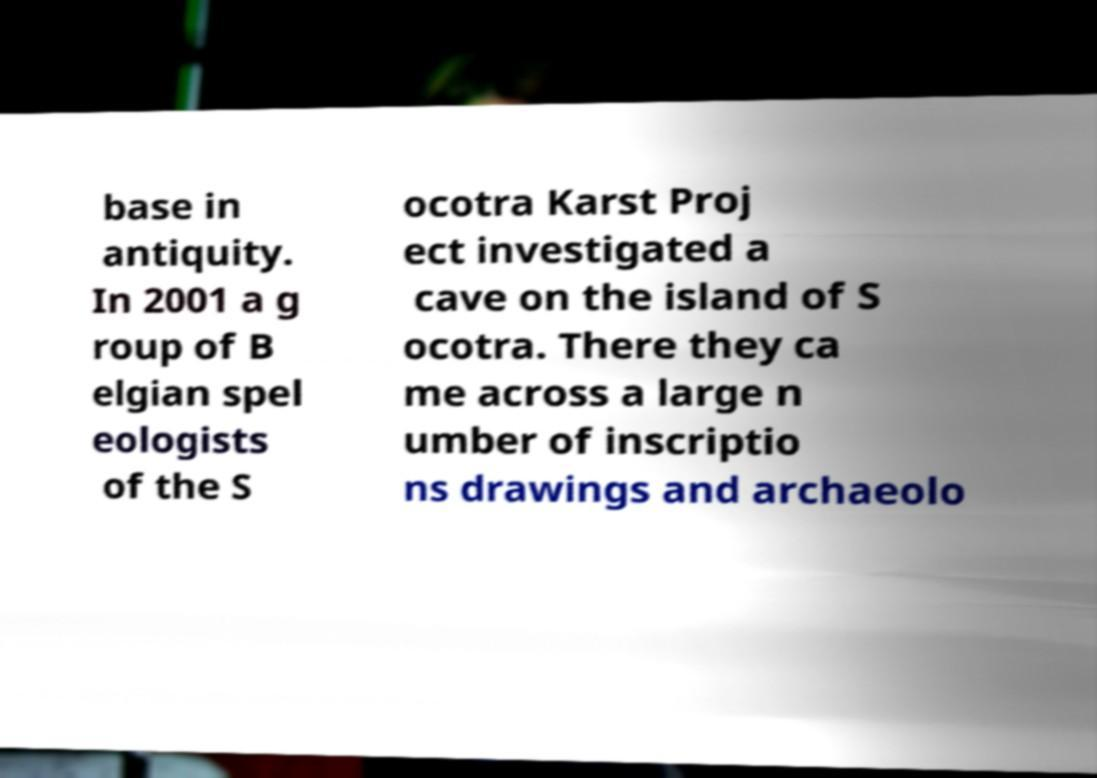Please read and relay the text visible in this image. What does it say? base in antiquity. In 2001 a g roup of B elgian spel eologists of the S ocotra Karst Proj ect investigated a cave on the island of S ocotra. There they ca me across a large n umber of inscriptio ns drawings and archaeolo 